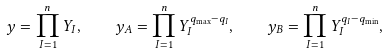<formula> <loc_0><loc_0><loc_500><loc_500>y = \prod _ { I = 1 } ^ { n } Y _ { I } , \quad y _ { A } = \prod _ { I = 1 } ^ { n } Y _ { I } ^ { q _ { \max } - q _ { I } } , \quad y _ { B } = \prod _ { I = 1 } ^ { n } Y _ { I } ^ { q _ { I } - q _ { \min } } ,</formula> 